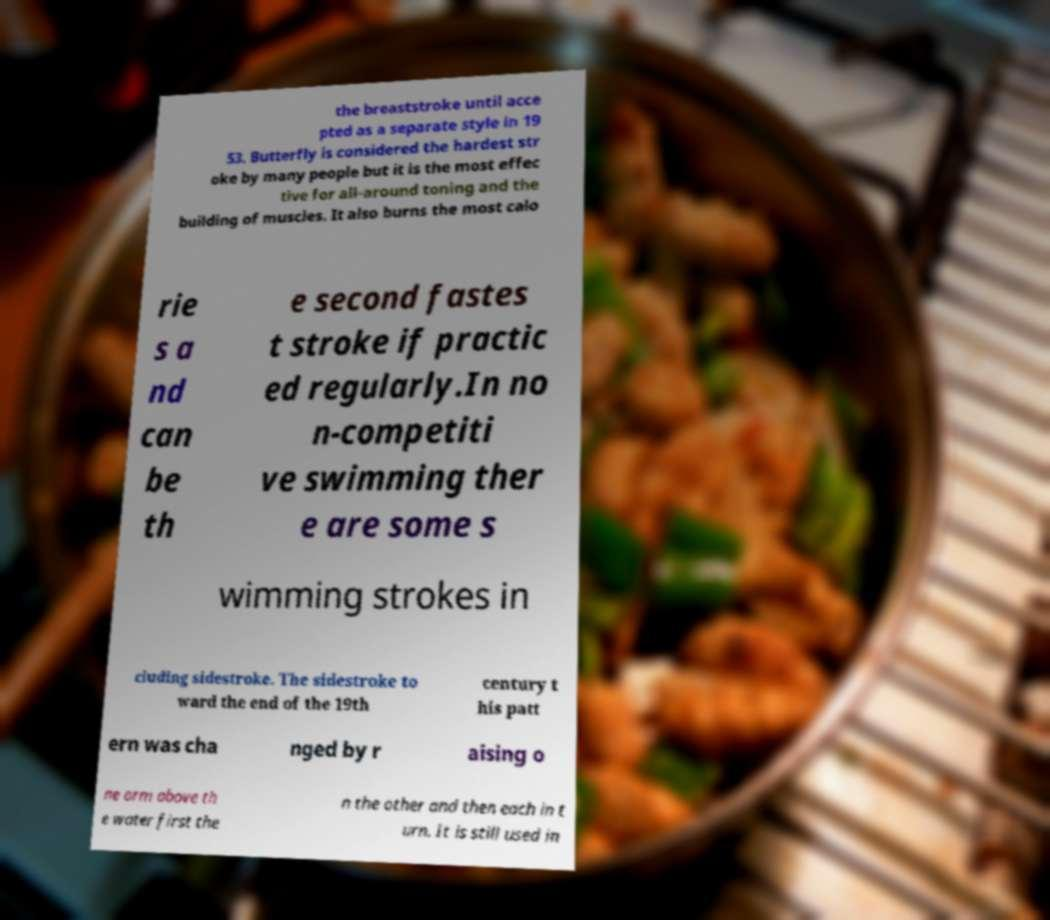What messages or text are displayed in this image? I need them in a readable, typed format. the breaststroke until acce pted as a separate style in 19 53. Butterfly is considered the hardest str oke by many people but it is the most effec tive for all-around toning and the building of muscles. It also burns the most calo rie s a nd can be th e second fastes t stroke if practic ed regularly.In no n-competiti ve swimming ther e are some s wimming strokes in cluding sidestroke. The sidestroke to ward the end of the 19th century t his patt ern was cha nged by r aising o ne arm above th e water first the n the other and then each in t urn. It is still used in 